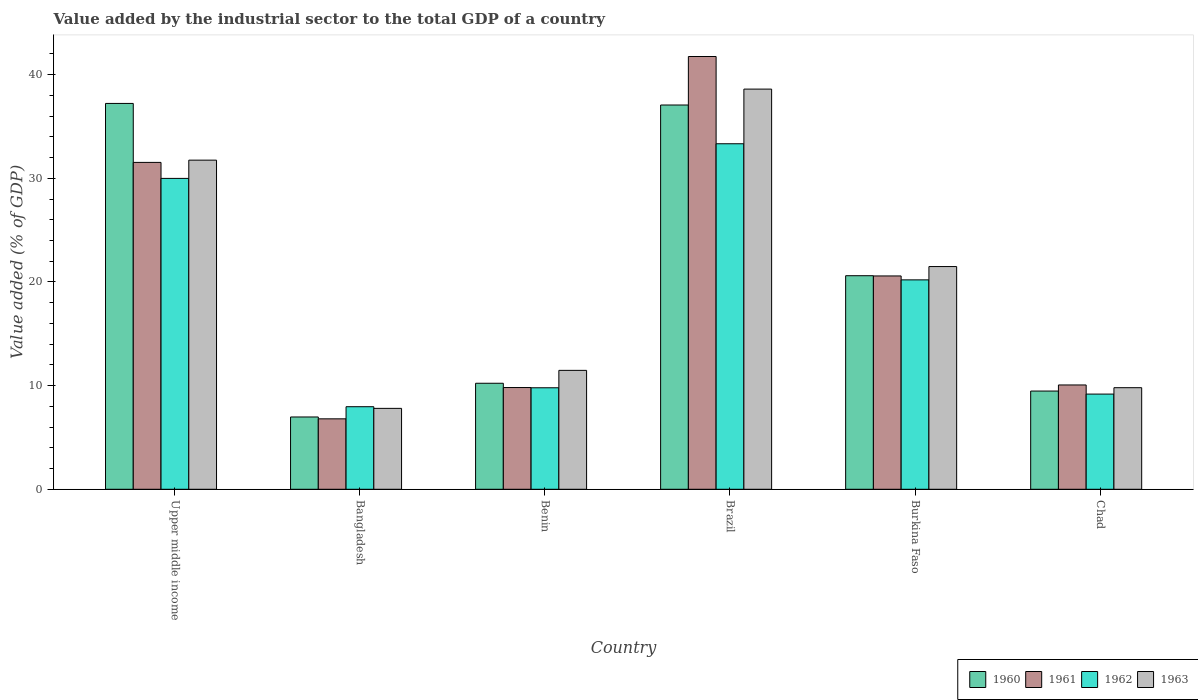How many different coloured bars are there?
Give a very brief answer. 4. How many bars are there on the 3rd tick from the right?
Make the answer very short. 4. In how many cases, is the number of bars for a given country not equal to the number of legend labels?
Offer a terse response. 0. What is the value added by the industrial sector to the total GDP in 1963 in Benin?
Offer a terse response. 11.47. Across all countries, what is the maximum value added by the industrial sector to the total GDP in 1962?
Your answer should be very brief. 33.33. Across all countries, what is the minimum value added by the industrial sector to the total GDP in 1960?
Ensure brevity in your answer.  6.97. In which country was the value added by the industrial sector to the total GDP in 1963 maximum?
Provide a succinct answer. Brazil. In which country was the value added by the industrial sector to the total GDP in 1962 minimum?
Offer a very short reply. Bangladesh. What is the total value added by the industrial sector to the total GDP in 1962 in the graph?
Ensure brevity in your answer.  110.45. What is the difference between the value added by the industrial sector to the total GDP in 1961 in Bangladesh and that in Chad?
Your answer should be compact. -3.27. What is the difference between the value added by the industrial sector to the total GDP in 1962 in Benin and the value added by the industrial sector to the total GDP in 1961 in Chad?
Your answer should be compact. -0.27. What is the average value added by the industrial sector to the total GDP in 1961 per country?
Make the answer very short. 20.09. What is the difference between the value added by the industrial sector to the total GDP of/in 1960 and value added by the industrial sector to the total GDP of/in 1963 in Benin?
Your answer should be very brief. -1.24. In how many countries, is the value added by the industrial sector to the total GDP in 1961 greater than 32 %?
Provide a succinct answer. 1. What is the ratio of the value added by the industrial sector to the total GDP in 1963 in Bangladesh to that in Upper middle income?
Provide a succinct answer. 0.25. What is the difference between the highest and the second highest value added by the industrial sector to the total GDP in 1960?
Offer a very short reply. 16.47. What is the difference between the highest and the lowest value added by the industrial sector to the total GDP in 1960?
Your response must be concise. 30.25. In how many countries, is the value added by the industrial sector to the total GDP in 1963 greater than the average value added by the industrial sector to the total GDP in 1963 taken over all countries?
Provide a succinct answer. 3. Are all the bars in the graph horizontal?
Make the answer very short. No. How many countries are there in the graph?
Provide a succinct answer. 6. What is the difference between two consecutive major ticks on the Y-axis?
Offer a terse response. 10. Are the values on the major ticks of Y-axis written in scientific E-notation?
Your answer should be very brief. No. How many legend labels are there?
Ensure brevity in your answer.  4. How are the legend labels stacked?
Your response must be concise. Horizontal. What is the title of the graph?
Give a very brief answer. Value added by the industrial sector to the total GDP of a country. Does "2008" appear as one of the legend labels in the graph?
Ensure brevity in your answer.  No. What is the label or title of the X-axis?
Provide a short and direct response. Country. What is the label or title of the Y-axis?
Keep it short and to the point. Value added (% of GDP). What is the Value added (% of GDP) in 1960 in Upper middle income?
Offer a very short reply. 37.22. What is the Value added (% of GDP) of 1961 in Upper middle income?
Ensure brevity in your answer.  31.53. What is the Value added (% of GDP) of 1962 in Upper middle income?
Provide a succinct answer. 29.99. What is the Value added (% of GDP) of 1963 in Upper middle income?
Offer a terse response. 31.75. What is the Value added (% of GDP) of 1960 in Bangladesh?
Make the answer very short. 6.97. What is the Value added (% of GDP) of 1961 in Bangladesh?
Offer a terse response. 6.79. What is the Value added (% of GDP) of 1962 in Bangladesh?
Provide a succinct answer. 7.96. What is the Value added (% of GDP) in 1963 in Bangladesh?
Offer a very short reply. 7.8. What is the Value added (% of GDP) in 1960 in Benin?
Give a very brief answer. 10.23. What is the Value added (% of GDP) of 1961 in Benin?
Provide a succinct answer. 9.81. What is the Value added (% of GDP) in 1962 in Benin?
Provide a short and direct response. 9.79. What is the Value added (% of GDP) in 1963 in Benin?
Make the answer very short. 11.47. What is the Value added (% of GDP) of 1960 in Brazil?
Provide a short and direct response. 37.07. What is the Value added (% of GDP) of 1961 in Brazil?
Ensure brevity in your answer.  41.75. What is the Value added (% of GDP) in 1962 in Brazil?
Keep it short and to the point. 33.33. What is the Value added (% of GDP) in 1963 in Brazil?
Make the answer very short. 38.6. What is the Value added (% of GDP) of 1960 in Burkina Faso?
Your answer should be compact. 20.6. What is the Value added (% of GDP) of 1961 in Burkina Faso?
Keep it short and to the point. 20.58. What is the Value added (% of GDP) of 1962 in Burkina Faso?
Your answer should be compact. 20.2. What is the Value added (% of GDP) of 1963 in Burkina Faso?
Offer a terse response. 21.48. What is the Value added (% of GDP) in 1960 in Chad?
Keep it short and to the point. 9.47. What is the Value added (% of GDP) in 1961 in Chad?
Keep it short and to the point. 10.06. What is the Value added (% of GDP) of 1962 in Chad?
Your answer should be very brief. 9.18. What is the Value added (% of GDP) in 1963 in Chad?
Your response must be concise. 9.8. Across all countries, what is the maximum Value added (% of GDP) of 1960?
Provide a succinct answer. 37.22. Across all countries, what is the maximum Value added (% of GDP) in 1961?
Give a very brief answer. 41.75. Across all countries, what is the maximum Value added (% of GDP) of 1962?
Your answer should be compact. 33.33. Across all countries, what is the maximum Value added (% of GDP) of 1963?
Your answer should be compact. 38.6. Across all countries, what is the minimum Value added (% of GDP) in 1960?
Your answer should be very brief. 6.97. Across all countries, what is the minimum Value added (% of GDP) of 1961?
Provide a succinct answer. 6.79. Across all countries, what is the minimum Value added (% of GDP) of 1962?
Ensure brevity in your answer.  7.96. Across all countries, what is the minimum Value added (% of GDP) in 1963?
Offer a terse response. 7.8. What is the total Value added (% of GDP) in 1960 in the graph?
Make the answer very short. 121.56. What is the total Value added (% of GDP) in 1961 in the graph?
Offer a terse response. 120.52. What is the total Value added (% of GDP) in 1962 in the graph?
Ensure brevity in your answer.  110.45. What is the total Value added (% of GDP) of 1963 in the graph?
Your answer should be compact. 120.91. What is the difference between the Value added (% of GDP) of 1960 in Upper middle income and that in Bangladesh?
Give a very brief answer. 30.25. What is the difference between the Value added (% of GDP) of 1961 in Upper middle income and that in Bangladesh?
Your response must be concise. 24.74. What is the difference between the Value added (% of GDP) in 1962 in Upper middle income and that in Bangladesh?
Your response must be concise. 22.02. What is the difference between the Value added (% of GDP) of 1963 in Upper middle income and that in Bangladesh?
Ensure brevity in your answer.  23.94. What is the difference between the Value added (% of GDP) in 1960 in Upper middle income and that in Benin?
Give a very brief answer. 26.99. What is the difference between the Value added (% of GDP) in 1961 in Upper middle income and that in Benin?
Ensure brevity in your answer.  21.72. What is the difference between the Value added (% of GDP) in 1962 in Upper middle income and that in Benin?
Provide a succinct answer. 20.2. What is the difference between the Value added (% of GDP) in 1963 in Upper middle income and that in Benin?
Keep it short and to the point. 20.28. What is the difference between the Value added (% of GDP) of 1960 in Upper middle income and that in Brazil?
Keep it short and to the point. 0.15. What is the difference between the Value added (% of GDP) of 1961 in Upper middle income and that in Brazil?
Offer a terse response. -10.21. What is the difference between the Value added (% of GDP) of 1962 in Upper middle income and that in Brazil?
Give a very brief answer. -3.34. What is the difference between the Value added (% of GDP) of 1963 in Upper middle income and that in Brazil?
Make the answer very short. -6.85. What is the difference between the Value added (% of GDP) of 1960 in Upper middle income and that in Burkina Faso?
Ensure brevity in your answer.  16.62. What is the difference between the Value added (% of GDP) in 1961 in Upper middle income and that in Burkina Faso?
Your response must be concise. 10.95. What is the difference between the Value added (% of GDP) in 1962 in Upper middle income and that in Burkina Faso?
Provide a short and direct response. 9.79. What is the difference between the Value added (% of GDP) in 1963 in Upper middle income and that in Burkina Faso?
Your response must be concise. 10.27. What is the difference between the Value added (% of GDP) of 1960 in Upper middle income and that in Chad?
Your answer should be compact. 27.75. What is the difference between the Value added (% of GDP) in 1961 in Upper middle income and that in Chad?
Offer a very short reply. 21.47. What is the difference between the Value added (% of GDP) of 1962 in Upper middle income and that in Chad?
Offer a terse response. 20.81. What is the difference between the Value added (% of GDP) in 1963 in Upper middle income and that in Chad?
Your answer should be compact. 21.95. What is the difference between the Value added (% of GDP) of 1960 in Bangladesh and that in Benin?
Give a very brief answer. -3.25. What is the difference between the Value added (% of GDP) in 1961 in Bangladesh and that in Benin?
Ensure brevity in your answer.  -3.02. What is the difference between the Value added (% of GDP) in 1962 in Bangladesh and that in Benin?
Give a very brief answer. -1.83. What is the difference between the Value added (% of GDP) in 1963 in Bangladesh and that in Benin?
Provide a succinct answer. -3.66. What is the difference between the Value added (% of GDP) of 1960 in Bangladesh and that in Brazil?
Provide a succinct answer. -30.09. What is the difference between the Value added (% of GDP) of 1961 in Bangladesh and that in Brazil?
Keep it short and to the point. -34.95. What is the difference between the Value added (% of GDP) of 1962 in Bangladesh and that in Brazil?
Offer a very short reply. -25.37. What is the difference between the Value added (% of GDP) in 1963 in Bangladesh and that in Brazil?
Your answer should be very brief. -30.8. What is the difference between the Value added (% of GDP) in 1960 in Bangladesh and that in Burkina Faso?
Give a very brief answer. -13.63. What is the difference between the Value added (% of GDP) of 1961 in Bangladesh and that in Burkina Faso?
Your answer should be very brief. -13.78. What is the difference between the Value added (% of GDP) in 1962 in Bangladesh and that in Burkina Faso?
Offer a terse response. -12.24. What is the difference between the Value added (% of GDP) in 1963 in Bangladesh and that in Burkina Faso?
Provide a succinct answer. -13.68. What is the difference between the Value added (% of GDP) of 1960 in Bangladesh and that in Chad?
Provide a succinct answer. -2.5. What is the difference between the Value added (% of GDP) of 1961 in Bangladesh and that in Chad?
Make the answer very short. -3.27. What is the difference between the Value added (% of GDP) of 1962 in Bangladesh and that in Chad?
Your answer should be compact. -1.22. What is the difference between the Value added (% of GDP) in 1963 in Bangladesh and that in Chad?
Your answer should be very brief. -1.99. What is the difference between the Value added (% of GDP) in 1960 in Benin and that in Brazil?
Offer a terse response. -26.84. What is the difference between the Value added (% of GDP) of 1961 in Benin and that in Brazil?
Your answer should be very brief. -31.93. What is the difference between the Value added (% of GDP) of 1962 in Benin and that in Brazil?
Provide a short and direct response. -23.54. What is the difference between the Value added (% of GDP) of 1963 in Benin and that in Brazil?
Your answer should be very brief. -27.13. What is the difference between the Value added (% of GDP) of 1960 in Benin and that in Burkina Faso?
Offer a very short reply. -10.37. What is the difference between the Value added (% of GDP) in 1961 in Benin and that in Burkina Faso?
Ensure brevity in your answer.  -10.76. What is the difference between the Value added (% of GDP) in 1962 in Benin and that in Burkina Faso?
Your answer should be very brief. -10.41. What is the difference between the Value added (% of GDP) of 1963 in Benin and that in Burkina Faso?
Offer a terse response. -10.01. What is the difference between the Value added (% of GDP) of 1960 in Benin and that in Chad?
Keep it short and to the point. 0.75. What is the difference between the Value added (% of GDP) of 1961 in Benin and that in Chad?
Your answer should be compact. -0.25. What is the difference between the Value added (% of GDP) of 1962 in Benin and that in Chad?
Keep it short and to the point. 0.61. What is the difference between the Value added (% of GDP) in 1963 in Benin and that in Chad?
Give a very brief answer. 1.67. What is the difference between the Value added (% of GDP) of 1960 in Brazil and that in Burkina Faso?
Offer a terse response. 16.47. What is the difference between the Value added (% of GDP) of 1961 in Brazil and that in Burkina Faso?
Your response must be concise. 21.17. What is the difference between the Value added (% of GDP) in 1962 in Brazil and that in Burkina Faso?
Offer a very short reply. 13.13. What is the difference between the Value added (% of GDP) of 1963 in Brazil and that in Burkina Faso?
Your answer should be compact. 17.12. What is the difference between the Value added (% of GDP) in 1960 in Brazil and that in Chad?
Make the answer very short. 27.59. What is the difference between the Value added (% of GDP) in 1961 in Brazil and that in Chad?
Your answer should be compact. 31.68. What is the difference between the Value added (% of GDP) of 1962 in Brazil and that in Chad?
Give a very brief answer. 24.15. What is the difference between the Value added (% of GDP) of 1963 in Brazil and that in Chad?
Your answer should be very brief. 28.8. What is the difference between the Value added (% of GDP) of 1960 in Burkina Faso and that in Chad?
Offer a terse response. 11.13. What is the difference between the Value added (% of GDP) of 1961 in Burkina Faso and that in Chad?
Give a very brief answer. 10.52. What is the difference between the Value added (% of GDP) of 1962 in Burkina Faso and that in Chad?
Your answer should be compact. 11.02. What is the difference between the Value added (% of GDP) in 1963 in Burkina Faso and that in Chad?
Ensure brevity in your answer.  11.68. What is the difference between the Value added (% of GDP) in 1960 in Upper middle income and the Value added (% of GDP) in 1961 in Bangladesh?
Your response must be concise. 30.43. What is the difference between the Value added (% of GDP) of 1960 in Upper middle income and the Value added (% of GDP) of 1962 in Bangladesh?
Ensure brevity in your answer.  29.26. What is the difference between the Value added (% of GDP) of 1960 in Upper middle income and the Value added (% of GDP) of 1963 in Bangladesh?
Your response must be concise. 29.42. What is the difference between the Value added (% of GDP) in 1961 in Upper middle income and the Value added (% of GDP) in 1962 in Bangladesh?
Ensure brevity in your answer.  23.57. What is the difference between the Value added (% of GDP) in 1961 in Upper middle income and the Value added (% of GDP) in 1963 in Bangladesh?
Offer a terse response. 23.73. What is the difference between the Value added (% of GDP) in 1962 in Upper middle income and the Value added (% of GDP) in 1963 in Bangladesh?
Your response must be concise. 22.18. What is the difference between the Value added (% of GDP) in 1960 in Upper middle income and the Value added (% of GDP) in 1961 in Benin?
Offer a very short reply. 27.41. What is the difference between the Value added (% of GDP) in 1960 in Upper middle income and the Value added (% of GDP) in 1962 in Benin?
Your answer should be compact. 27.43. What is the difference between the Value added (% of GDP) of 1960 in Upper middle income and the Value added (% of GDP) of 1963 in Benin?
Provide a short and direct response. 25.75. What is the difference between the Value added (% of GDP) in 1961 in Upper middle income and the Value added (% of GDP) in 1962 in Benin?
Offer a very short reply. 21.74. What is the difference between the Value added (% of GDP) in 1961 in Upper middle income and the Value added (% of GDP) in 1963 in Benin?
Provide a short and direct response. 20.06. What is the difference between the Value added (% of GDP) of 1962 in Upper middle income and the Value added (% of GDP) of 1963 in Benin?
Ensure brevity in your answer.  18.52. What is the difference between the Value added (% of GDP) of 1960 in Upper middle income and the Value added (% of GDP) of 1961 in Brazil?
Provide a succinct answer. -4.53. What is the difference between the Value added (% of GDP) in 1960 in Upper middle income and the Value added (% of GDP) in 1962 in Brazil?
Offer a terse response. 3.89. What is the difference between the Value added (% of GDP) of 1960 in Upper middle income and the Value added (% of GDP) of 1963 in Brazil?
Offer a very short reply. -1.38. What is the difference between the Value added (% of GDP) of 1961 in Upper middle income and the Value added (% of GDP) of 1962 in Brazil?
Keep it short and to the point. -1.8. What is the difference between the Value added (% of GDP) of 1961 in Upper middle income and the Value added (% of GDP) of 1963 in Brazil?
Provide a short and direct response. -7.07. What is the difference between the Value added (% of GDP) of 1962 in Upper middle income and the Value added (% of GDP) of 1963 in Brazil?
Your response must be concise. -8.61. What is the difference between the Value added (% of GDP) of 1960 in Upper middle income and the Value added (% of GDP) of 1961 in Burkina Faso?
Make the answer very short. 16.64. What is the difference between the Value added (% of GDP) of 1960 in Upper middle income and the Value added (% of GDP) of 1962 in Burkina Faso?
Offer a very short reply. 17.02. What is the difference between the Value added (% of GDP) of 1960 in Upper middle income and the Value added (% of GDP) of 1963 in Burkina Faso?
Ensure brevity in your answer.  15.74. What is the difference between the Value added (% of GDP) in 1961 in Upper middle income and the Value added (% of GDP) in 1962 in Burkina Faso?
Offer a terse response. 11.33. What is the difference between the Value added (% of GDP) of 1961 in Upper middle income and the Value added (% of GDP) of 1963 in Burkina Faso?
Offer a very short reply. 10.05. What is the difference between the Value added (% of GDP) of 1962 in Upper middle income and the Value added (% of GDP) of 1963 in Burkina Faso?
Keep it short and to the point. 8.5. What is the difference between the Value added (% of GDP) of 1960 in Upper middle income and the Value added (% of GDP) of 1961 in Chad?
Offer a very short reply. 27.16. What is the difference between the Value added (% of GDP) in 1960 in Upper middle income and the Value added (% of GDP) in 1962 in Chad?
Make the answer very short. 28.04. What is the difference between the Value added (% of GDP) of 1960 in Upper middle income and the Value added (% of GDP) of 1963 in Chad?
Provide a succinct answer. 27.42. What is the difference between the Value added (% of GDP) of 1961 in Upper middle income and the Value added (% of GDP) of 1962 in Chad?
Offer a very short reply. 22.35. What is the difference between the Value added (% of GDP) in 1961 in Upper middle income and the Value added (% of GDP) in 1963 in Chad?
Your answer should be very brief. 21.73. What is the difference between the Value added (% of GDP) of 1962 in Upper middle income and the Value added (% of GDP) of 1963 in Chad?
Your answer should be compact. 20.19. What is the difference between the Value added (% of GDP) of 1960 in Bangladesh and the Value added (% of GDP) of 1961 in Benin?
Offer a terse response. -2.84. What is the difference between the Value added (% of GDP) of 1960 in Bangladesh and the Value added (% of GDP) of 1962 in Benin?
Provide a succinct answer. -2.82. What is the difference between the Value added (% of GDP) of 1960 in Bangladesh and the Value added (% of GDP) of 1963 in Benin?
Your answer should be very brief. -4.5. What is the difference between the Value added (% of GDP) in 1961 in Bangladesh and the Value added (% of GDP) in 1962 in Benin?
Keep it short and to the point. -3. What is the difference between the Value added (% of GDP) in 1961 in Bangladesh and the Value added (% of GDP) in 1963 in Benin?
Ensure brevity in your answer.  -4.68. What is the difference between the Value added (% of GDP) of 1962 in Bangladesh and the Value added (% of GDP) of 1963 in Benin?
Provide a short and direct response. -3.51. What is the difference between the Value added (% of GDP) in 1960 in Bangladesh and the Value added (% of GDP) in 1961 in Brazil?
Give a very brief answer. -34.77. What is the difference between the Value added (% of GDP) in 1960 in Bangladesh and the Value added (% of GDP) in 1962 in Brazil?
Make the answer very short. -26.36. What is the difference between the Value added (% of GDP) in 1960 in Bangladesh and the Value added (% of GDP) in 1963 in Brazil?
Provide a succinct answer. -31.63. What is the difference between the Value added (% of GDP) of 1961 in Bangladesh and the Value added (% of GDP) of 1962 in Brazil?
Give a very brief answer. -26.53. What is the difference between the Value added (% of GDP) of 1961 in Bangladesh and the Value added (% of GDP) of 1963 in Brazil?
Keep it short and to the point. -31.81. What is the difference between the Value added (% of GDP) of 1962 in Bangladesh and the Value added (% of GDP) of 1963 in Brazil?
Provide a short and direct response. -30.64. What is the difference between the Value added (% of GDP) of 1960 in Bangladesh and the Value added (% of GDP) of 1961 in Burkina Faso?
Offer a very short reply. -13.6. What is the difference between the Value added (% of GDP) in 1960 in Bangladesh and the Value added (% of GDP) in 1962 in Burkina Faso?
Offer a terse response. -13.23. What is the difference between the Value added (% of GDP) of 1960 in Bangladesh and the Value added (% of GDP) of 1963 in Burkina Faso?
Ensure brevity in your answer.  -14.51. What is the difference between the Value added (% of GDP) in 1961 in Bangladesh and the Value added (% of GDP) in 1962 in Burkina Faso?
Your answer should be compact. -13.41. What is the difference between the Value added (% of GDP) of 1961 in Bangladesh and the Value added (% of GDP) of 1963 in Burkina Faso?
Your response must be concise. -14.69. What is the difference between the Value added (% of GDP) in 1962 in Bangladesh and the Value added (% of GDP) in 1963 in Burkina Faso?
Make the answer very short. -13.52. What is the difference between the Value added (% of GDP) of 1960 in Bangladesh and the Value added (% of GDP) of 1961 in Chad?
Provide a short and direct response. -3.09. What is the difference between the Value added (% of GDP) in 1960 in Bangladesh and the Value added (% of GDP) in 1962 in Chad?
Give a very brief answer. -2.21. What is the difference between the Value added (% of GDP) of 1960 in Bangladesh and the Value added (% of GDP) of 1963 in Chad?
Give a very brief answer. -2.83. What is the difference between the Value added (% of GDP) in 1961 in Bangladesh and the Value added (% of GDP) in 1962 in Chad?
Your answer should be compact. -2.39. What is the difference between the Value added (% of GDP) of 1961 in Bangladesh and the Value added (% of GDP) of 1963 in Chad?
Your answer should be compact. -3. What is the difference between the Value added (% of GDP) in 1962 in Bangladesh and the Value added (% of GDP) in 1963 in Chad?
Ensure brevity in your answer.  -1.84. What is the difference between the Value added (% of GDP) in 1960 in Benin and the Value added (% of GDP) in 1961 in Brazil?
Keep it short and to the point. -31.52. What is the difference between the Value added (% of GDP) of 1960 in Benin and the Value added (% of GDP) of 1962 in Brazil?
Your response must be concise. -23.1. What is the difference between the Value added (% of GDP) of 1960 in Benin and the Value added (% of GDP) of 1963 in Brazil?
Your answer should be very brief. -28.37. What is the difference between the Value added (% of GDP) of 1961 in Benin and the Value added (% of GDP) of 1962 in Brazil?
Keep it short and to the point. -23.52. What is the difference between the Value added (% of GDP) in 1961 in Benin and the Value added (% of GDP) in 1963 in Brazil?
Give a very brief answer. -28.79. What is the difference between the Value added (% of GDP) of 1962 in Benin and the Value added (% of GDP) of 1963 in Brazil?
Give a very brief answer. -28.81. What is the difference between the Value added (% of GDP) in 1960 in Benin and the Value added (% of GDP) in 1961 in Burkina Faso?
Keep it short and to the point. -10.35. What is the difference between the Value added (% of GDP) in 1960 in Benin and the Value added (% of GDP) in 1962 in Burkina Faso?
Your answer should be very brief. -9.97. What is the difference between the Value added (% of GDP) of 1960 in Benin and the Value added (% of GDP) of 1963 in Burkina Faso?
Ensure brevity in your answer.  -11.26. What is the difference between the Value added (% of GDP) of 1961 in Benin and the Value added (% of GDP) of 1962 in Burkina Faso?
Keep it short and to the point. -10.39. What is the difference between the Value added (% of GDP) in 1961 in Benin and the Value added (% of GDP) in 1963 in Burkina Faso?
Your response must be concise. -11.67. What is the difference between the Value added (% of GDP) in 1962 in Benin and the Value added (% of GDP) in 1963 in Burkina Faso?
Offer a very short reply. -11.69. What is the difference between the Value added (% of GDP) of 1960 in Benin and the Value added (% of GDP) of 1961 in Chad?
Offer a terse response. 0.16. What is the difference between the Value added (% of GDP) in 1960 in Benin and the Value added (% of GDP) in 1962 in Chad?
Provide a short and direct response. 1.05. What is the difference between the Value added (% of GDP) of 1960 in Benin and the Value added (% of GDP) of 1963 in Chad?
Ensure brevity in your answer.  0.43. What is the difference between the Value added (% of GDP) of 1961 in Benin and the Value added (% of GDP) of 1962 in Chad?
Your answer should be very brief. 0.63. What is the difference between the Value added (% of GDP) in 1961 in Benin and the Value added (% of GDP) in 1963 in Chad?
Your response must be concise. 0.01. What is the difference between the Value added (% of GDP) in 1962 in Benin and the Value added (% of GDP) in 1963 in Chad?
Provide a short and direct response. -0.01. What is the difference between the Value added (% of GDP) of 1960 in Brazil and the Value added (% of GDP) of 1961 in Burkina Faso?
Offer a very short reply. 16.49. What is the difference between the Value added (% of GDP) in 1960 in Brazil and the Value added (% of GDP) in 1962 in Burkina Faso?
Offer a terse response. 16.87. What is the difference between the Value added (% of GDP) of 1960 in Brazil and the Value added (% of GDP) of 1963 in Burkina Faso?
Give a very brief answer. 15.58. What is the difference between the Value added (% of GDP) in 1961 in Brazil and the Value added (% of GDP) in 1962 in Burkina Faso?
Your response must be concise. 21.54. What is the difference between the Value added (% of GDP) of 1961 in Brazil and the Value added (% of GDP) of 1963 in Burkina Faso?
Offer a very short reply. 20.26. What is the difference between the Value added (% of GDP) of 1962 in Brazil and the Value added (% of GDP) of 1963 in Burkina Faso?
Your answer should be compact. 11.85. What is the difference between the Value added (% of GDP) in 1960 in Brazil and the Value added (% of GDP) in 1961 in Chad?
Make the answer very short. 27. What is the difference between the Value added (% of GDP) of 1960 in Brazil and the Value added (% of GDP) of 1962 in Chad?
Give a very brief answer. 27.88. What is the difference between the Value added (% of GDP) of 1960 in Brazil and the Value added (% of GDP) of 1963 in Chad?
Make the answer very short. 27.27. What is the difference between the Value added (% of GDP) of 1961 in Brazil and the Value added (% of GDP) of 1962 in Chad?
Ensure brevity in your answer.  32.56. What is the difference between the Value added (% of GDP) of 1961 in Brazil and the Value added (% of GDP) of 1963 in Chad?
Your answer should be very brief. 31.95. What is the difference between the Value added (% of GDP) of 1962 in Brazil and the Value added (% of GDP) of 1963 in Chad?
Ensure brevity in your answer.  23.53. What is the difference between the Value added (% of GDP) of 1960 in Burkina Faso and the Value added (% of GDP) of 1961 in Chad?
Make the answer very short. 10.54. What is the difference between the Value added (% of GDP) of 1960 in Burkina Faso and the Value added (% of GDP) of 1962 in Chad?
Your answer should be compact. 11.42. What is the difference between the Value added (% of GDP) in 1960 in Burkina Faso and the Value added (% of GDP) in 1963 in Chad?
Your answer should be compact. 10.8. What is the difference between the Value added (% of GDP) in 1961 in Burkina Faso and the Value added (% of GDP) in 1962 in Chad?
Offer a very short reply. 11.4. What is the difference between the Value added (% of GDP) in 1961 in Burkina Faso and the Value added (% of GDP) in 1963 in Chad?
Make the answer very short. 10.78. What is the difference between the Value added (% of GDP) of 1962 in Burkina Faso and the Value added (% of GDP) of 1963 in Chad?
Make the answer very short. 10.4. What is the average Value added (% of GDP) of 1960 per country?
Offer a very short reply. 20.26. What is the average Value added (% of GDP) in 1961 per country?
Provide a succinct answer. 20.09. What is the average Value added (% of GDP) in 1962 per country?
Give a very brief answer. 18.41. What is the average Value added (% of GDP) of 1963 per country?
Provide a short and direct response. 20.15. What is the difference between the Value added (% of GDP) of 1960 and Value added (% of GDP) of 1961 in Upper middle income?
Your answer should be compact. 5.69. What is the difference between the Value added (% of GDP) of 1960 and Value added (% of GDP) of 1962 in Upper middle income?
Your answer should be very brief. 7.23. What is the difference between the Value added (% of GDP) in 1960 and Value added (% of GDP) in 1963 in Upper middle income?
Provide a succinct answer. 5.47. What is the difference between the Value added (% of GDP) of 1961 and Value added (% of GDP) of 1962 in Upper middle income?
Provide a short and direct response. 1.54. What is the difference between the Value added (% of GDP) of 1961 and Value added (% of GDP) of 1963 in Upper middle income?
Offer a very short reply. -0.22. What is the difference between the Value added (% of GDP) in 1962 and Value added (% of GDP) in 1963 in Upper middle income?
Your answer should be compact. -1.76. What is the difference between the Value added (% of GDP) in 1960 and Value added (% of GDP) in 1961 in Bangladesh?
Your answer should be very brief. 0.18. What is the difference between the Value added (% of GDP) of 1960 and Value added (% of GDP) of 1962 in Bangladesh?
Your response must be concise. -0.99. What is the difference between the Value added (% of GDP) in 1960 and Value added (% of GDP) in 1963 in Bangladesh?
Your response must be concise. -0.83. What is the difference between the Value added (% of GDP) of 1961 and Value added (% of GDP) of 1962 in Bangladesh?
Ensure brevity in your answer.  -1.17. What is the difference between the Value added (% of GDP) in 1961 and Value added (% of GDP) in 1963 in Bangladesh?
Offer a terse response. -1.01. What is the difference between the Value added (% of GDP) in 1962 and Value added (% of GDP) in 1963 in Bangladesh?
Your response must be concise. 0.16. What is the difference between the Value added (% of GDP) in 1960 and Value added (% of GDP) in 1961 in Benin?
Your answer should be compact. 0.41. What is the difference between the Value added (% of GDP) in 1960 and Value added (% of GDP) in 1962 in Benin?
Offer a terse response. 0.44. What is the difference between the Value added (% of GDP) of 1960 and Value added (% of GDP) of 1963 in Benin?
Provide a short and direct response. -1.24. What is the difference between the Value added (% of GDP) in 1961 and Value added (% of GDP) in 1962 in Benin?
Provide a succinct answer. 0.02. What is the difference between the Value added (% of GDP) of 1961 and Value added (% of GDP) of 1963 in Benin?
Provide a succinct answer. -1.66. What is the difference between the Value added (% of GDP) in 1962 and Value added (% of GDP) in 1963 in Benin?
Your answer should be very brief. -1.68. What is the difference between the Value added (% of GDP) of 1960 and Value added (% of GDP) of 1961 in Brazil?
Provide a short and direct response. -4.68. What is the difference between the Value added (% of GDP) in 1960 and Value added (% of GDP) in 1962 in Brazil?
Provide a short and direct response. 3.74. What is the difference between the Value added (% of GDP) of 1960 and Value added (% of GDP) of 1963 in Brazil?
Offer a very short reply. -1.53. What is the difference between the Value added (% of GDP) of 1961 and Value added (% of GDP) of 1962 in Brazil?
Ensure brevity in your answer.  8.42. What is the difference between the Value added (% of GDP) of 1961 and Value added (% of GDP) of 1963 in Brazil?
Keep it short and to the point. 3.14. What is the difference between the Value added (% of GDP) of 1962 and Value added (% of GDP) of 1963 in Brazil?
Provide a short and direct response. -5.27. What is the difference between the Value added (% of GDP) in 1960 and Value added (% of GDP) in 1961 in Burkina Faso?
Your response must be concise. 0.02. What is the difference between the Value added (% of GDP) of 1960 and Value added (% of GDP) of 1962 in Burkina Faso?
Your answer should be very brief. 0.4. What is the difference between the Value added (% of GDP) of 1960 and Value added (% of GDP) of 1963 in Burkina Faso?
Offer a very short reply. -0.88. What is the difference between the Value added (% of GDP) of 1961 and Value added (% of GDP) of 1962 in Burkina Faso?
Offer a very short reply. 0.38. What is the difference between the Value added (% of GDP) of 1961 and Value added (% of GDP) of 1963 in Burkina Faso?
Offer a very short reply. -0.91. What is the difference between the Value added (% of GDP) in 1962 and Value added (% of GDP) in 1963 in Burkina Faso?
Provide a short and direct response. -1.28. What is the difference between the Value added (% of GDP) in 1960 and Value added (% of GDP) in 1961 in Chad?
Your answer should be very brief. -0.59. What is the difference between the Value added (% of GDP) of 1960 and Value added (% of GDP) of 1962 in Chad?
Your answer should be very brief. 0.29. What is the difference between the Value added (% of GDP) of 1960 and Value added (% of GDP) of 1963 in Chad?
Your answer should be compact. -0.32. What is the difference between the Value added (% of GDP) of 1961 and Value added (% of GDP) of 1962 in Chad?
Give a very brief answer. 0.88. What is the difference between the Value added (% of GDP) in 1961 and Value added (% of GDP) in 1963 in Chad?
Your answer should be compact. 0.26. What is the difference between the Value added (% of GDP) in 1962 and Value added (% of GDP) in 1963 in Chad?
Offer a terse response. -0.62. What is the ratio of the Value added (% of GDP) in 1960 in Upper middle income to that in Bangladesh?
Make the answer very short. 5.34. What is the ratio of the Value added (% of GDP) of 1961 in Upper middle income to that in Bangladesh?
Keep it short and to the point. 4.64. What is the ratio of the Value added (% of GDP) of 1962 in Upper middle income to that in Bangladesh?
Keep it short and to the point. 3.77. What is the ratio of the Value added (% of GDP) in 1963 in Upper middle income to that in Bangladesh?
Your response must be concise. 4.07. What is the ratio of the Value added (% of GDP) in 1960 in Upper middle income to that in Benin?
Your response must be concise. 3.64. What is the ratio of the Value added (% of GDP) in 1961 in Upper middle income to that in Benin?
Your response must be concise. 3.21. What is the ratio of the Value added (% of GDP) in 1962 in Upper middle income to that in Benin?
Keep it short and to the point. 3.06. What is the ratio of the Value added (% of GDP) in 1963 in Upper middle income to that in Benin?
Your response must be concise. 2.77. What is the ratio of the Value added (% of GDP) of 1960 in Upper middle income to that in Brazil?
Make the answer very short. 1. What is the ratio of the Value added (% of GDP) of 1961 in Upper middle income to that in Brazil?
Give a very brief answer. 0.76. What is the ratio of the Value added (% of GDP) in 1962 in Upper middle income to that in Brazil?
Keep it short and to the point. 0.9. What is the ratio of the Value added (% of GDP) in 1963 in Upper middle income to that in Brazil?
Keep it short and to the point. 0.82. What is the ratio of the Value added (% of GDP) of 1960 in Upper middle income to that in Burkina Faso?
Provide a succinct answer. 1.81. What is the ratio of the Value added (% of GDP) of 1961 in Upper middle income to that in Burkina Faso?
Provide a succinct answer. 1.53. What is the ratio of the Value added (% of GDP) of 1962 in Upper middle income to that in Burkina Faso?
Keep it short and to the point. 1.48. What is the ratio of the Value added (% of GDP) of 1963 in Upper middle income to that in Burkina Faso?
Offer a very short reply. 1.48. What is the ratio of the Value added (% of GDP) of 1960 in Upper middle income to that in Chad?
Offer a very short reply. 3.93. What is the ratio of the Value added (% of GDP) in 1961 in Upper middle income to that in Chad?
Offer a terse response. 3.13. What is the ratio of the Value added (% of GDP) in 1962 in Upper middle income to that in Chad?
Offer a terse response. 3.27. What is the ratio of the Value added (% of GDP) of 1963 in Upper middle income to that in Chad?
Offer a very short reply. 3.24. What is the ratio of the Value added (% of GDP) in 1960 in Bangladesh to that in Benin?
Give a very brief answer. 0.68. What is the ratio of the Value added (% of GDP) of 1961 in Bangladesh to that in Benin?
Provide a short and direct response. 0.69. What is the ratio of the Value added (% of GDP) in 1962 in Bangladesh to that in Benin?
Keep it short and to the point. 0.81. What is the ratio of the Value added (% of GDP) of 1963 in Bangladesh to that in Benin?
Your response must be concise. 0.68. What is the ratio of the Value added (% of GDP) in 1960 in Bangladesh to that in Brazil?
Ensure brevity in your answer.  0.19. What is the ratio of the Value added (% of GDP) in 1961 in Bangladesh to that in Brazil?
Offer a terse response. 0.16. What is the ratio of the Value added (% of GDP) in 1962 in Bangladesh to that in Brazil?
Provide a succinct answer. 0.24. What is the ratio of the Value added (% of GDP) of 1963 in Bangladesh to that in Brazil?
Give a very brief answer. 0.2. What is the ratio of the Value added (% of GDP) of 1960 in Bangladesh to that in Burkina Faso?
Make the answer very short. 0.34. What is the ratio of the Value added (% of GDP) in 1961 in Bangladesh to that in Burkina Faso?
Provide a short and direct response. 0.33. What is the ratio of the Value added (% of GDP) of 1962 in Bangladesh to that in Burkina Faso?
Make the answer very short. 0.39. What is the ratio of the Value added (% of GDP) of 1963 in Bangladesh to that in Burkina Faso?
Your answer should be very brief. 0.36. What is the ratio of the Value added (% of GDP) in 1960 in Bangladesh to that in Chad?
Make the answer very short. 0.74. What is the ratio of the Value added (% of GDP) of 1961 in Bangladesh to that in Chad?
Your answer should be very brief. 0.68. What is the ratio of the Value added (% of GDP) of 1962 in Bangladesh to that in Chad?
Make the answer very short. 0.87. What is the ratio of the Value added (% of GDP) of 1963 in Bangladesh to that in Chad?
Offer a very short reply. 0.8. What is the ratio of the Value added (% of GDP) of 1960 in Benin to that in Brazil?
Your answer should be compact. 0.28. What is the ratio of the Value added (% of GDP) in 1961 in Benin to that in Brazil?
Provide a succinct answer. 0.24. What is the ratio of the Value added (% of GDP) of 1962 in Benin to that in Brazil?
Make the answer very short. 0.29. What is the ratio of the Value added (% of GDP) of 1963 in Benin to that in Brazil?
Provide a succinct answer. 0.3. What is the ratio of the Value added (% of GDP) in 1960 in Benin to that in Burkina Faso?
Provide a short and direct response. 0.5. What is the ratio of the Value added (% of GDP) of 1961 in Benin to that in Burkina Faso?
Provide a short and direct response. 0.48. What is the ratio of the Value added (% of GDP) in 1962 in Benin to that in Burkina Faso?
Offer a terse response. 0.48. What is the ratio of the Value added (% of GDP) in 1963 in Benin to that in Burkina Faso?
Offer a very short reply. 0.53. What is the ratio of the Value added (% of GDP) of 1960 in Benin to that in Chad?
Your answer should be very brief. 1.08. What is the ratio of the Value added (% of GDP) of 1961 in Benin to that in Chad?
Your response must be concise. 0.98. What is the ratio of the Value added (% of GDP) of 1962 in Benin to that in Chad?
Your response must be concise. 1.07. What is the ratio of the Value added (% of GDP) in 1963 in Benin to that in Chad?
Ensure brevity in your answer.  1.17. What is the ratio of the Value added (% of GDP) of 1960 in Brazil to that in Burkina Faso?
Make the answer very short. 1.8. What is the ratio of the Value added (% of GDP) of 1961 in Brazil to that in Burkina Faso?
Provide a short and direct response. 2.03. What is the ratio of the Value added (% of GDP) of 1962 in Brazil to that in Burkina Faso?
Your response must be concise. 1.65. What is the ratio of the Value added (% of GDP) of 1963 in Brazil to that in Burkina Faso?
Your answer should be compact. 1.8. What is the ratio of the Value added (% of GDP) in 1960 in Brazil to that in Chad?
Offer a very short reply. 3.91. What is the ratio of the Value added (% of GDP) of 1961 in Brazil to that in Chad?
Provide a short and direct response. 4.15. What is the ratio of the Value added (% of GDP) of 1962 in Brazil to that in Chad?
Your answer should be compact. 3.63. What is the ratio of the Value added (% of GDP) in 1963 in Brazil to that in Chad?
Offer a very short reply. 3.94. What is the ratio of the Value added (% of GDP) of 1960 in Burkina Faso to that in Chad?
Offer a terse response. 2.17. What is the ratio of the Value added (% of GDP) in 1961 in Burkina Faso to that in Chad?
Your answer should be very brief. 2.04. What is the ratio of the Value added (% of GDP) in 1962 in Burkina Faso to that in Chad?
Ensure brevity in your answer.  2.2. What is the ratio of the Value added (% of GDP) in 1963 in Burkina Faso to that in Chad?
Make the answer very short. 2.19. What is the difference between the highest and the second highest Value added (% of GDP) in 1960?
Offer a terse response. 0.15. What is the difference between the highest and the second highest Value added (% of GDP) of 1961?
Offer a terse response. 10.21. What is the difference between the highest and the second highest Value added (% of GDP) in 1962?
Offer a terse response. 3.34. What is the difference between the highest and the second highest Value added (% of GDP) in 1963?
Your answer should be compact. 6.85. What is the difference between the highest and the lowest Value added (% of GDP) in 1960?
Your answer should be very brief. 30.25. What is the difference between the highest and the lowest Value added (% of GDP) in 1961?
Ensure brevity in your answer.  34.95. What is the difference between the highest and the lowest Value added (% of GDP) in 1962?
Offer a terse response. 25.37. What is the difference between the highest and the lowest Value added (% of GDP) in 1963?
Keep it short and to the point. 30.8. 